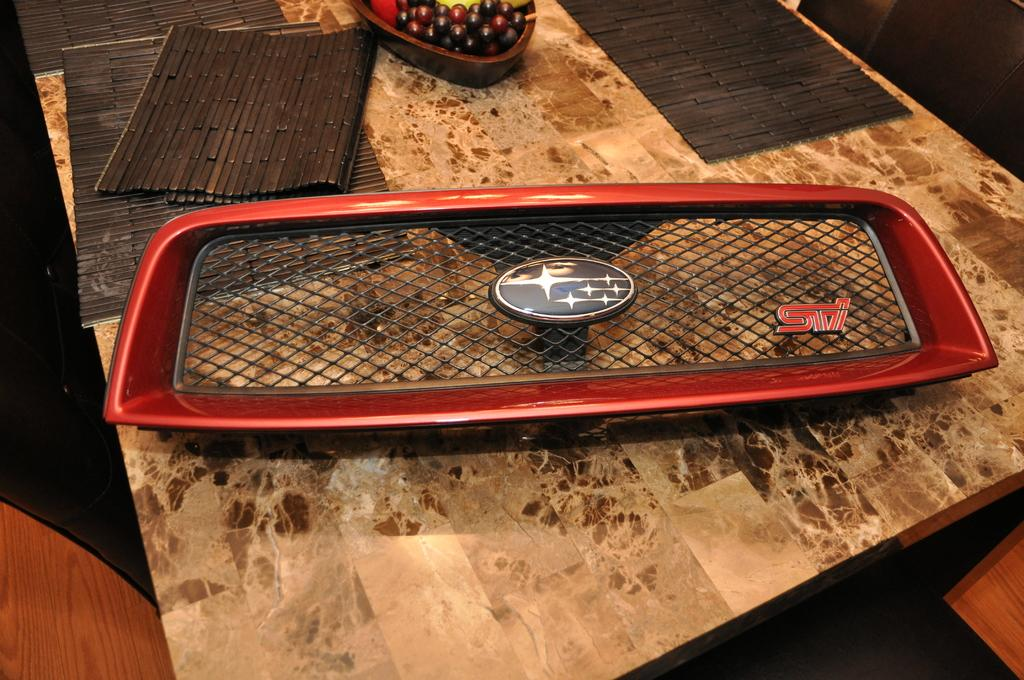What is the main object on the table in the image? There is an object on the table, but the specific object is not mentioned in the facts. What is used to protect the table from heat or scratches in the image? There are table mats on the table in the image. What type of food can be seen on the table? There is a bowl with fruits on the table. What type of twig is used as a decoration on the table in the image? There is no twig present in the image. What type of box is placed next to the bowl of fruits in the image? There is no box mentioned or visible in the image. 